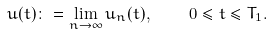<formula> <loc_0><loc_0><loc_500><loc_500>u ( t ) \colon = \lim _ { n \to \infty } u _ { n } ( t ) , \quad 0 \leq t \leq T _ { 1 } .</formula> 